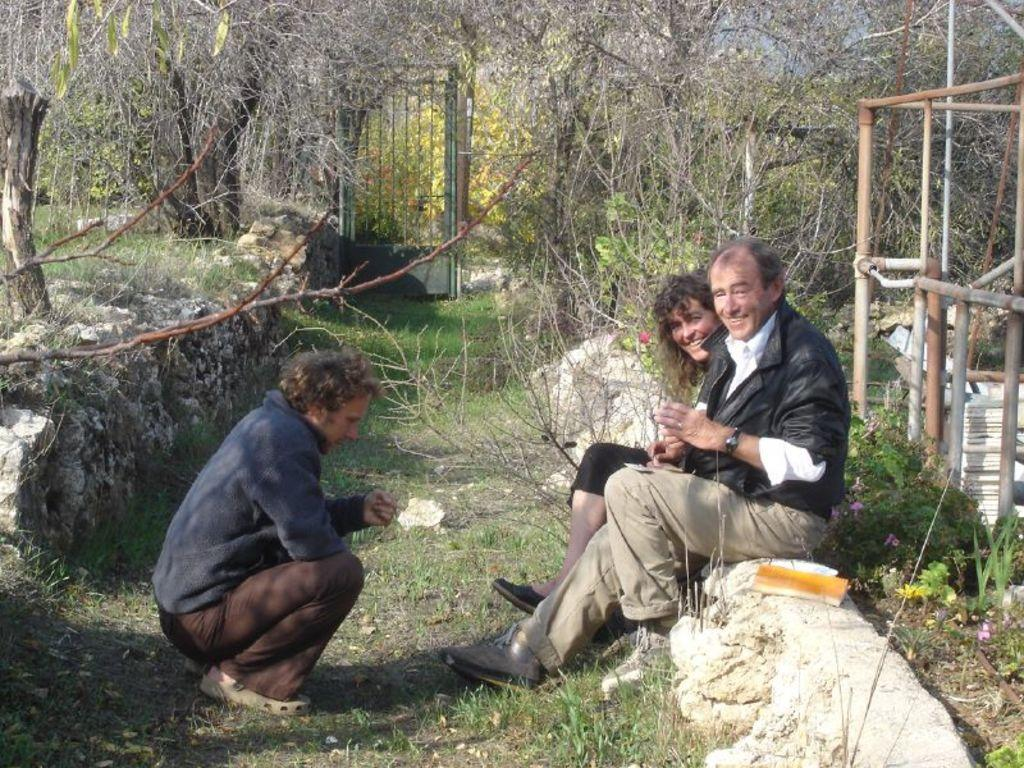How many people are sitting on the platform in the image? There are two people sitting on the platform in the image. What expressions do the people have? The people are smiling in the image. How is one of the people sitting? One person is sitting in a squat position. What type of vegetation can be seen in the image? There is grass, plants, flowers, and trees visible in the image. What object is present in the image? There is an object in the image, but its specific nature is not mentioned in the facts. What architectural feature can be seen in the image? There is a gate in the image. What type of animal is visible in the image? There is no animal present in the image. Can you tell me the price of the item on the receipt in the image? There is no receipt present in the image. 